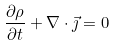Convert formula to latex. <formula><loc_0><loc_0><loc_500><loc_500>\frac { \partial \rho } { \partial t } + \nabla \cdot \vec { \jmath } = 0</formula> 